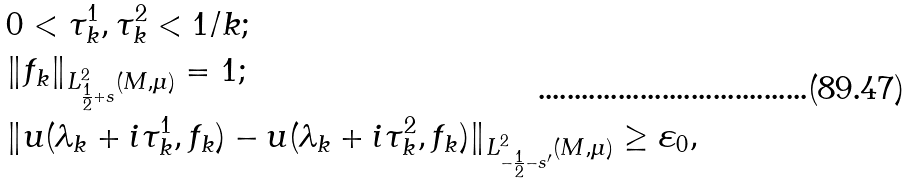<formula> <loc_0><loc_0><loc_500><loc_500>& 0 < \tau _ { k } ^ { 1 } , \tau _ { k } ^ { 2 } < 1 / k ; \\ & \| f _ { k } \| _ { L ^ { 2 } _ { \frac { 1 } { 2 } + s } ( M , \mu ) } = 1 ; \\ & \| u ( \lambda _ { k } + i \tau _ { k } ^ { 1 } , f _ { k } ) - u ( \lambda _ { k } + i \tau _ { k } ^ { 2 } , f _ { k } ) \| _ { L ^ { 2 } _ { - \frac { 1 } { 2 } - s ^ { \prime } } ( M , \mu ) } \geq \varepsilon _ { 0 } ,</formula> 